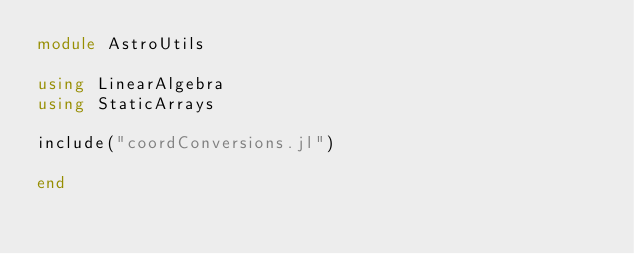<code> <loc_0><loc_0><loc_500><loc_500><_Julia_>module AstroUtils

using LinearAlgebra
using StaticArrays

include("coordConversions.jl")

end
</code> 